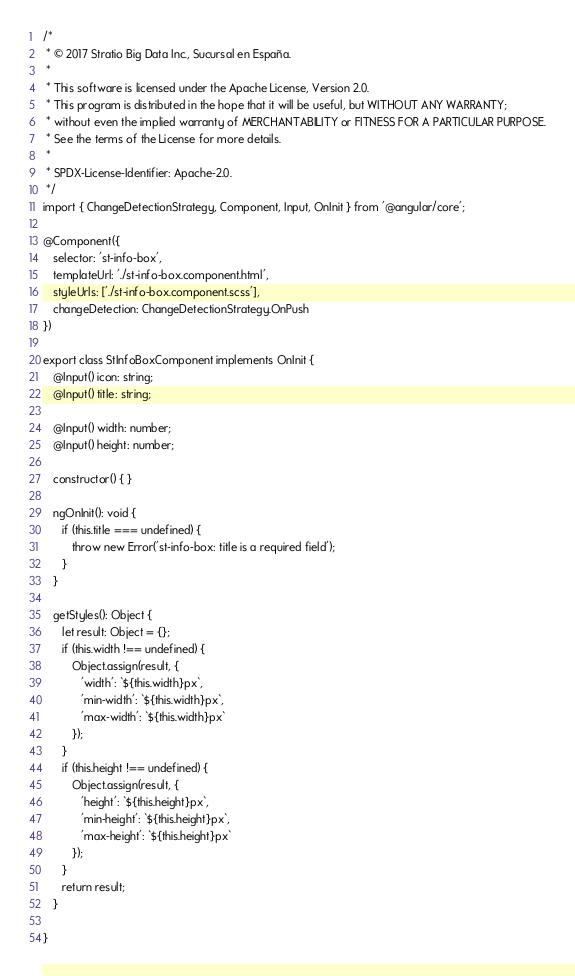<code> <loc_0><loc_0><loc_500><loc_500><_TypeScript_>/*
 * © 2017 Stratio Big Data Inc., Sucursal en España.
 *
 * This software is licensed under the Apache License, Version 2.0.
 * This program is distributed in the hope that it will be useful, but WITHOUT ANY WARRANTY;
 * without even the implied warranty of MERCHANTABILITY or FITNESS FOR A PARTICULAR PURPOSE.
 * See the terms of the License for more details.
 *
 * SPDX-License-Identifier: Apache-2.0.
 */
import { ChangeDetectionStrategy, Component, Input, OnInit } from '@angular/core';

@Component({
   selector: 'st-info-box',
   templateUrl: './st-info-box.component.html',
   styleUrls: ['./st-info-box.component.scss'],
   changeDetection: ChangeDetectionStrategy.OnPush
})

export class StInfoBoxComponent implements OnInit {
   @Input() icon: string;
   @Input() title: string;

   @Input() width: number;
   @Input() height: number;

   constructor() { }

   ngOnInit(): void {
      if (this.title === undefined) {
         throw new Error('st-info-box: title is a required field');
      }
   }

   getStyles(): Object {
      let result: Object = {};
      if (this.width !== undefined) {
         Object.assign(result, {
            'width': `${this.width}px`,
            'min-width': `${this.width}px`,
            'max-width': `${this.width}px`
         });
      }
      if (this.height !== undefined) {
         Object.assign(result, {
            'height': `${this.height}px`,
            'min-height': `${this.height}px`,
            'max-height': `${this.height}px`
         });
      }
      return result;
   }

}
</code> 